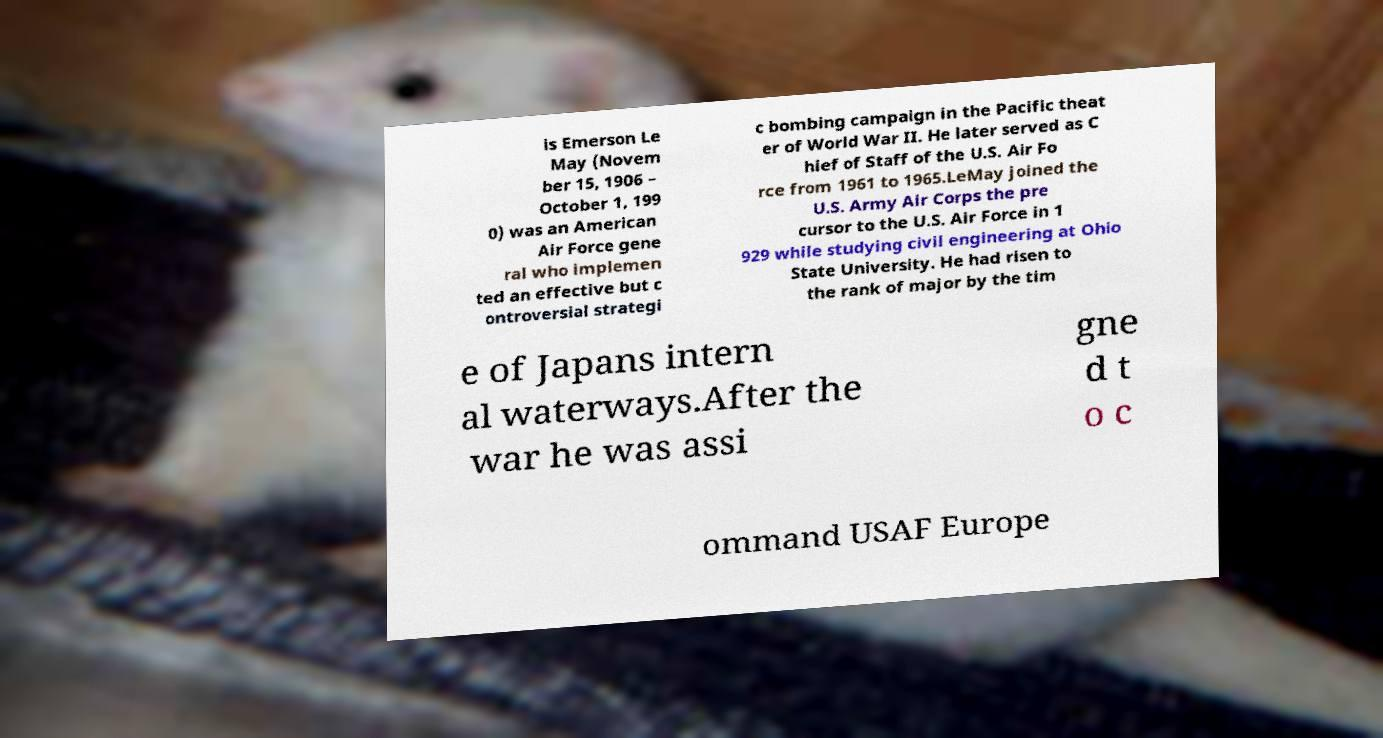Please identify and transcribe the text found in this image. is Emerson Le May (Novem ber 15, 1906 – October 1, 199 0) was an American Air Force gene ral who implemen ted an effective but c ontroversial strategi c bombing campaign in the Pacific theat er of World War II. He later served as C hief of Staff of the U.S. Air Fo rce from 1961 to 1965.LeMay joined the U.S. Army Air Corps the pre cursor to the U.S. Air Force in 1 929 while studying civil engineering at Ohio State University. He had risen to the rank of major by the tim e of Japans intern al waterways.After the war he was assi gne d t o c ommand USAF Europe 